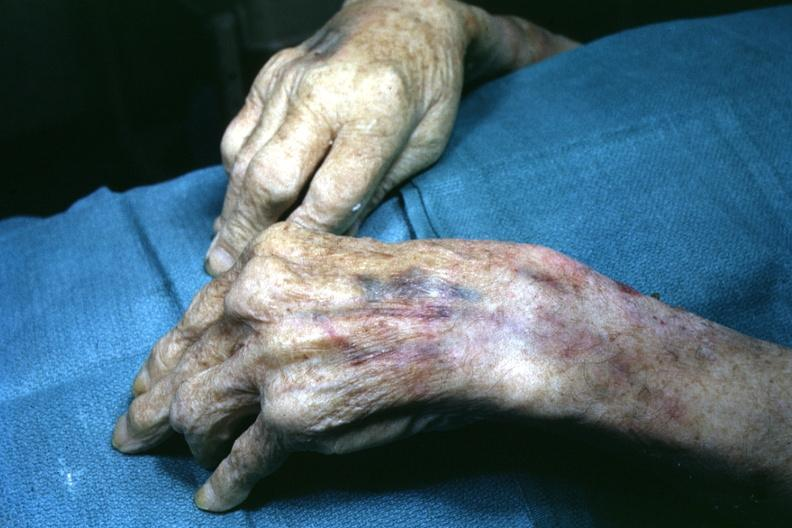what does this image show?
Answer the question using a single word or phrase. View of both hand with enlarged joints 